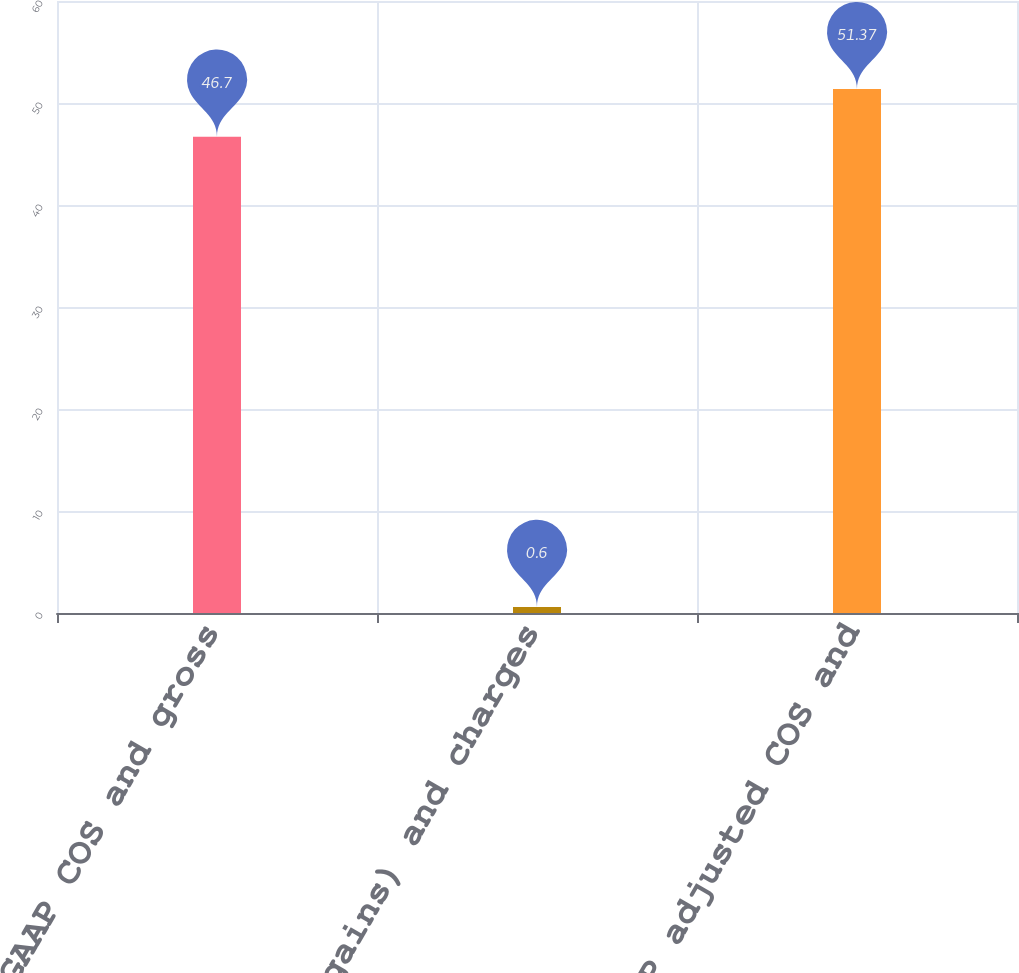Convert chart. <chart><loc_0><loc_0><loc_500><loc_500><bar_chart><fcel>Reported GAAP COS and gross<fcel>Special (gains) and charges<fcel>Non-GAAP adjusted COS and<nl><fcel>46.7<fcel>0.6<fcel>51.37<nl></chart> 